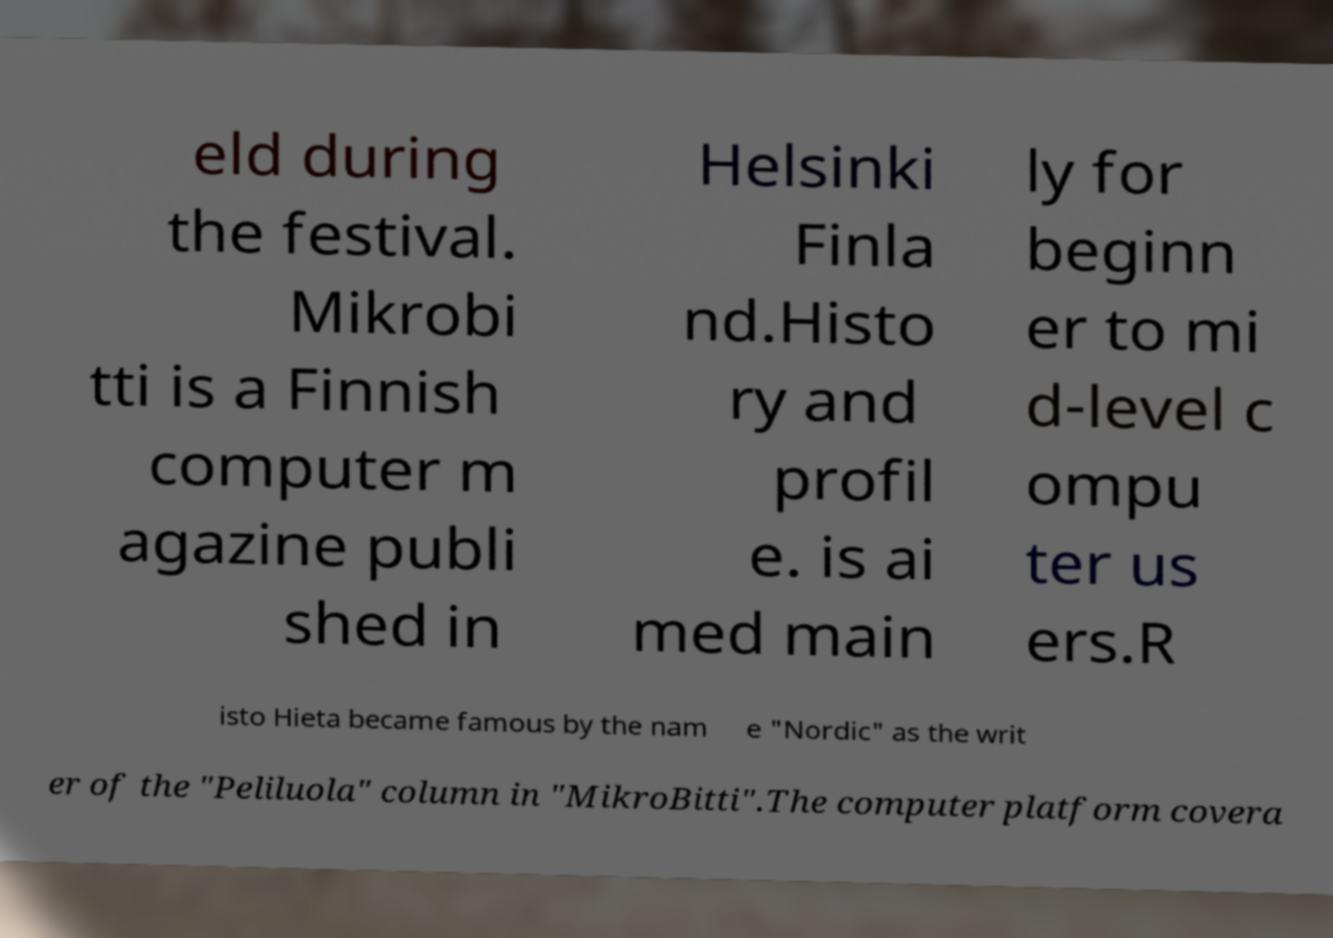What messages or text are displayed in this image? I need them in a readable, typed format. eld during the festival. Mikrobi tti is a Finnish computer m agazine publi shed in Helsinki Finla nd.Histo ry and profil e. is ai med main ly for beginn er to mi d-level c ompu ter us ers.R isto Hieta became famous by the nam e "Nordic" as the writ er of the "Peliluola" column in "MikroBitti".The computer platform covera 